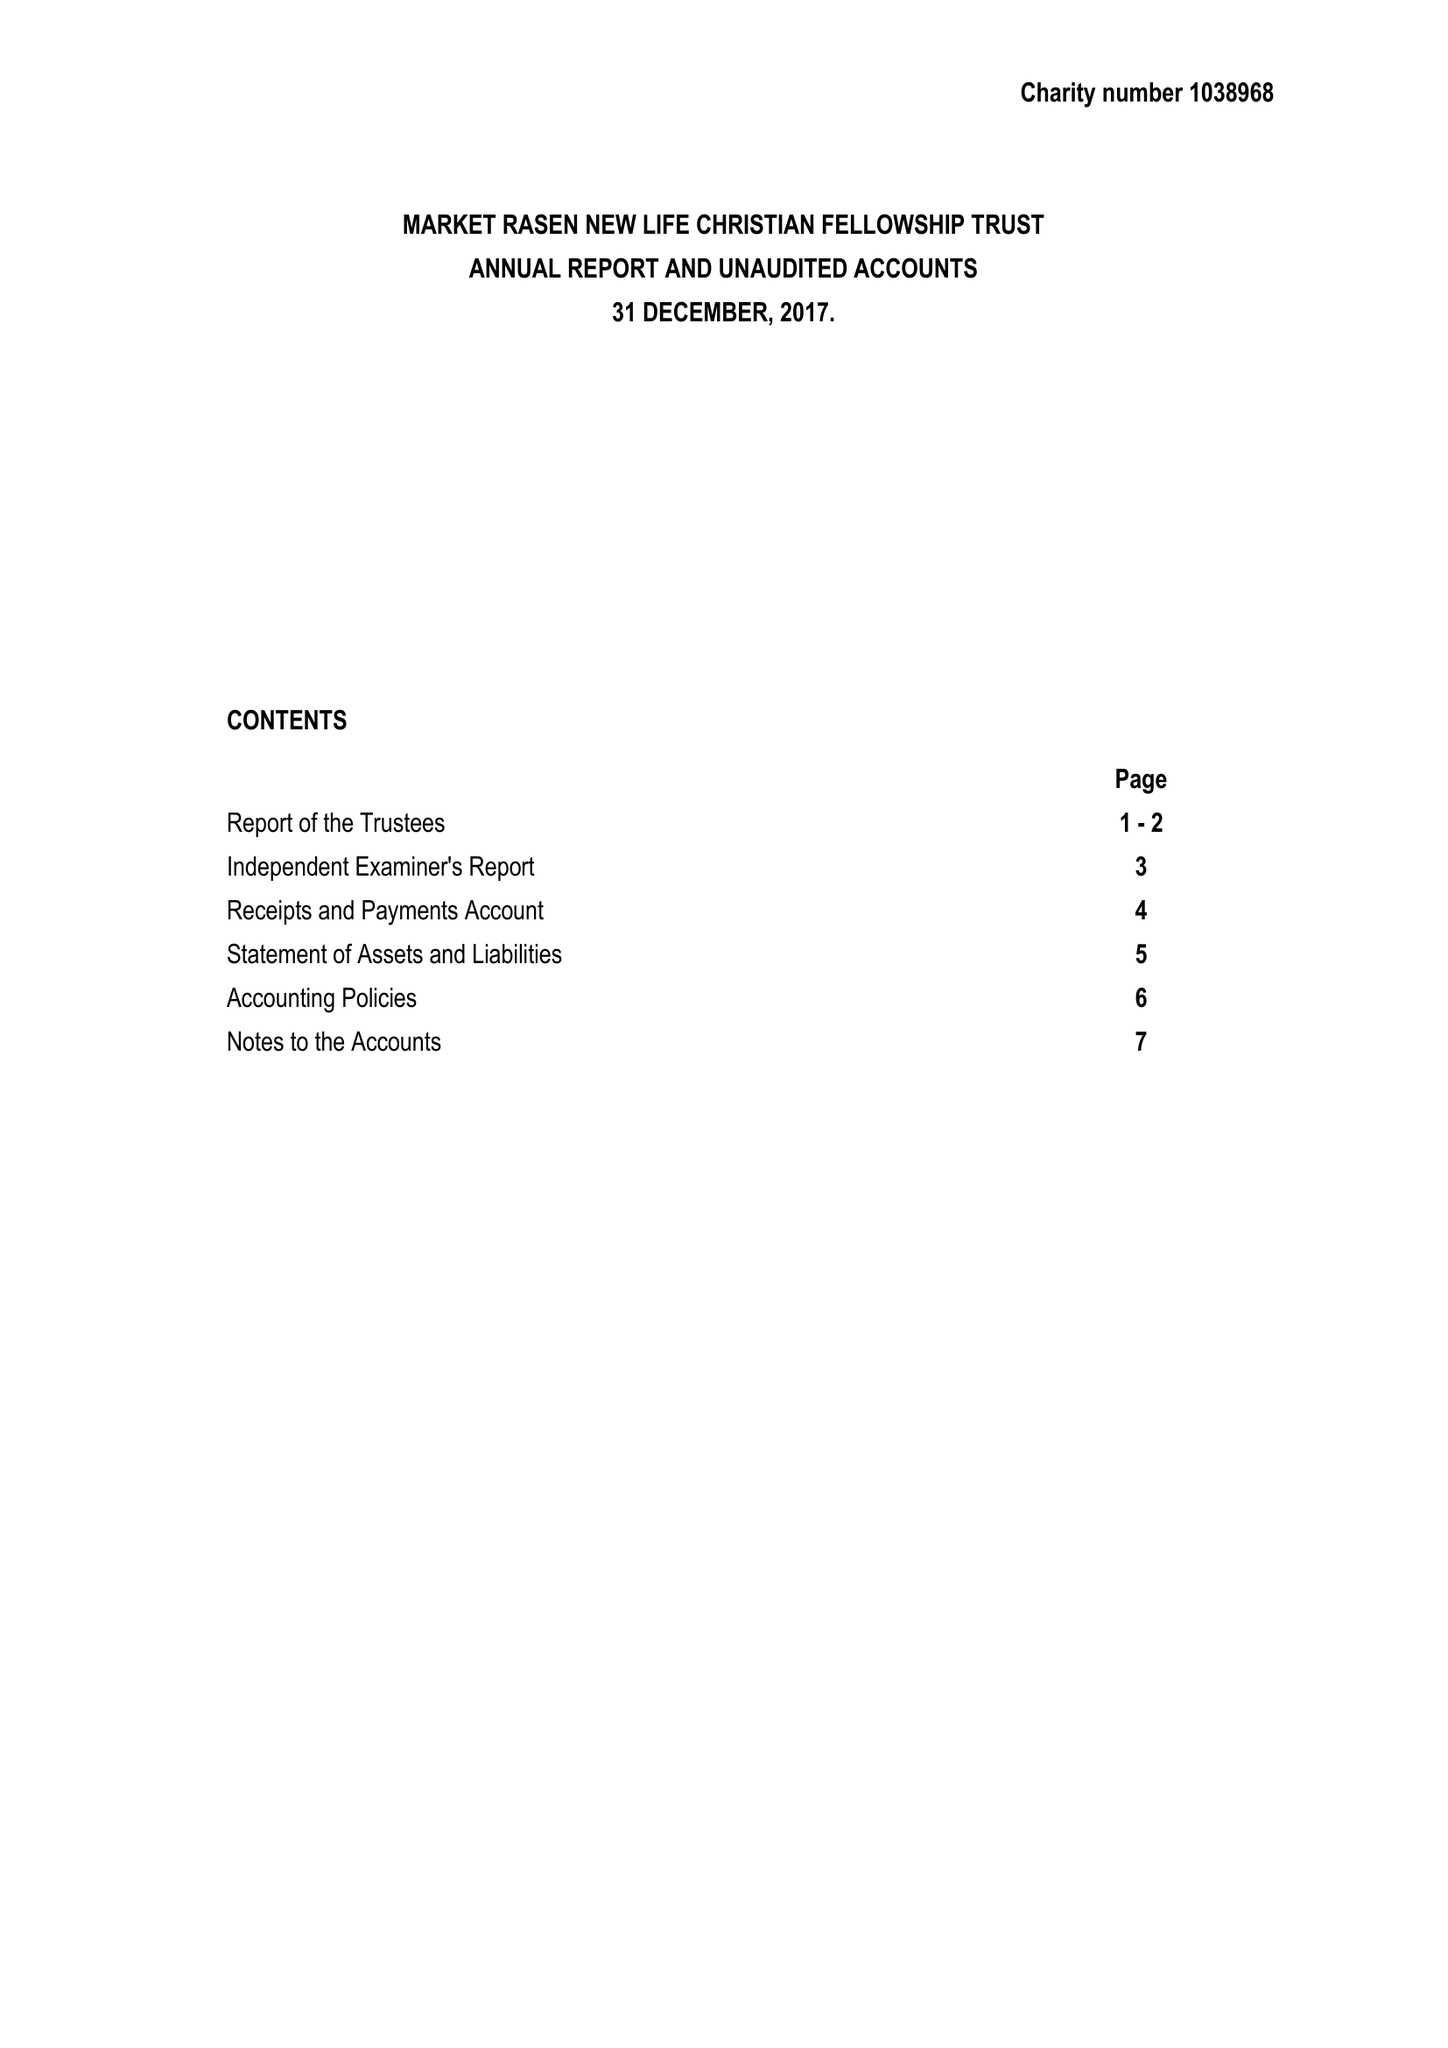What is the value for the address__post_town?
Answer the question using a single word or phrase. MARKET RASEN 